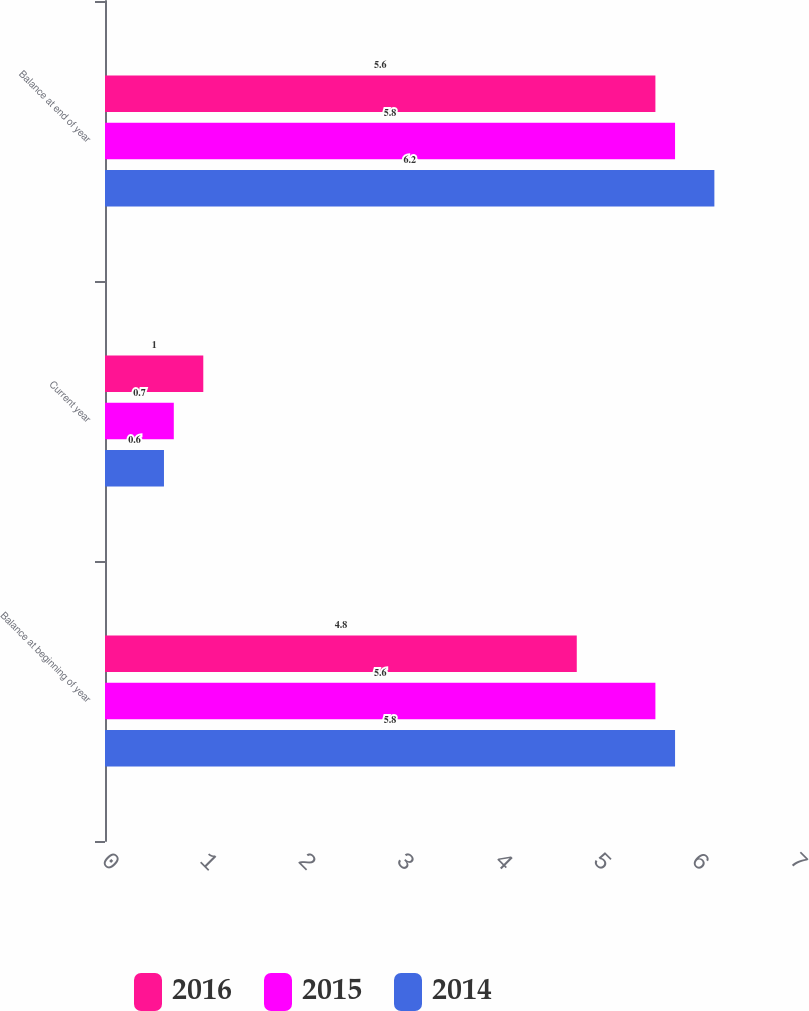Convert chart to OTSL. <chart><loc_0><loc_0><loc_500><loc_500><stacked_bar_chart><ecel><fcel>Balance at beginning of year<fcel>Current year<fcel>Balance at end of year<nl><fcel>2016<fcel>4.8<fcel>1<fcel>5.6<nl><fcel>2015<fcel>5.6<fcel>0.7<fcel>5.8<nl><fcel>2014<fcel>5.8<fcel>0.6<fcel>6.2<nl></chart> 